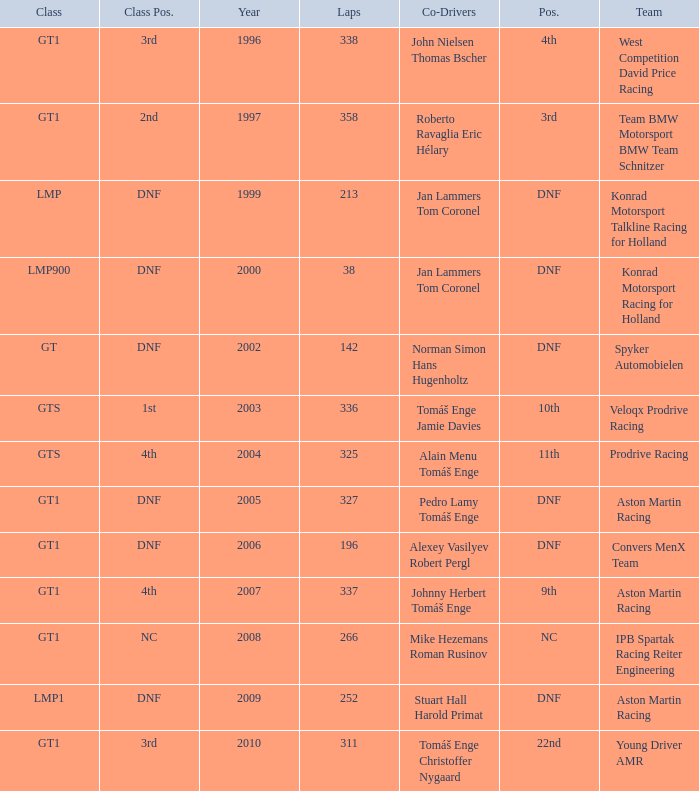Which team finished 3rd in class with 337 laps before 2008? West Competition David Price Racing. 